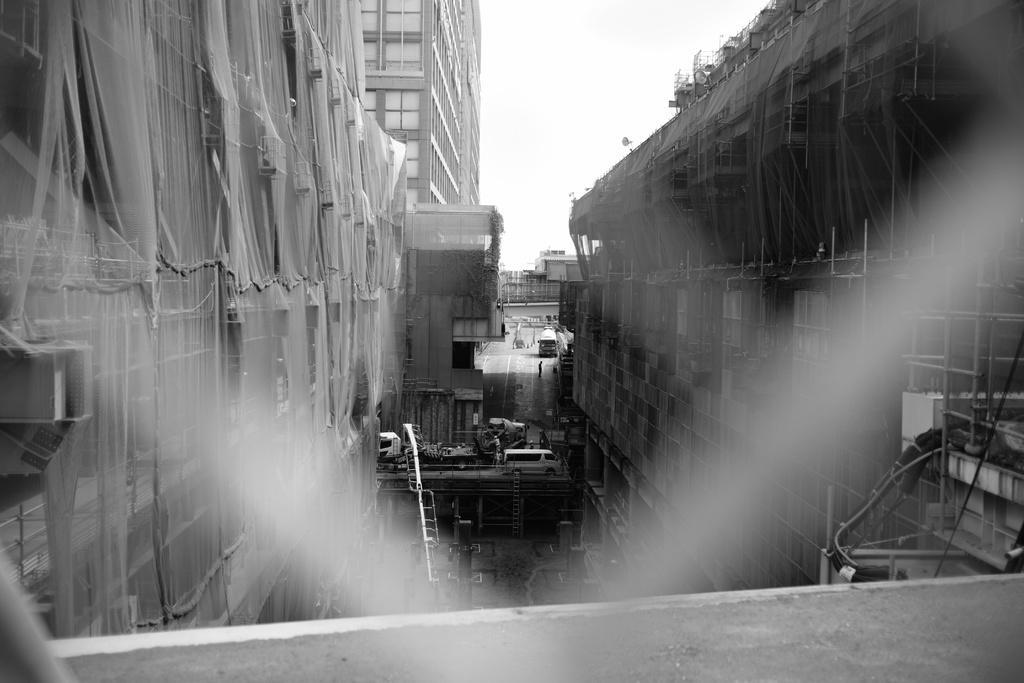Describe this image in one or two sentences. In this image we can see few buildings. In the foreground we can see nets on the buildings. In the background, we can see vehicles. At the top we can see the sky. 